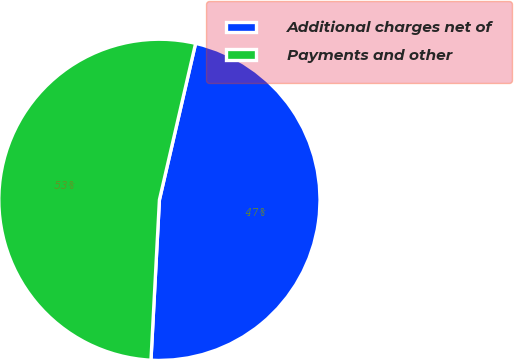<chart> <loc_0><loc_0><loc_500><loc_500><pie_chart><fcel>Additional charges net of<fcel>Payments and other<nl><fcel>47.22%<fcel>52.78%<nl></chart> 